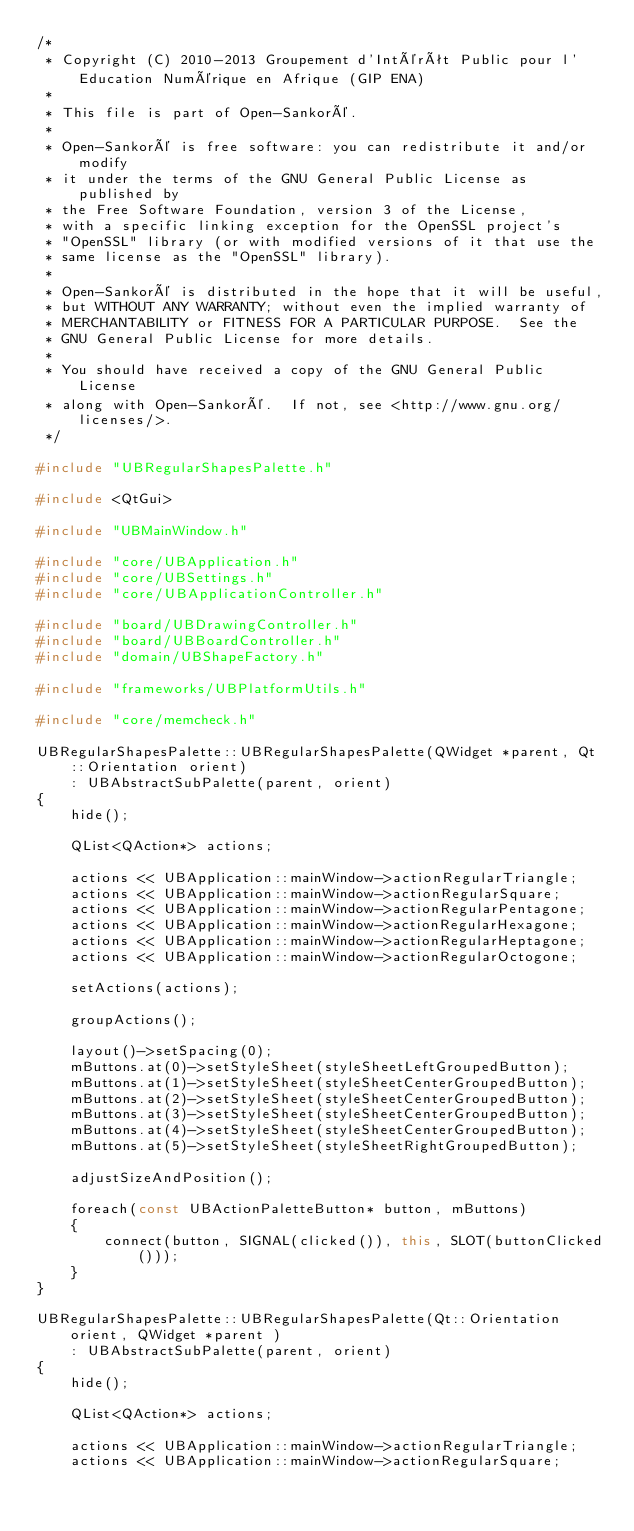<code> <loc_0><loc_0><loc_500><loc_500><_C++_>/*
 * Copyright (C) 2010-2013 Groupement d'Intérêt Public pour l'Education Numérique en Afrique (GIP ENA)
 *
 * This file is part of Open-Sankoré.
 *
 * Open-Sankoré is free software: you can redistribute it and/or modify
 * it under the terms of the GNU General Public License as published by
 * the Free Software Foundation, version 3 of the License,
 * with a specific linking exception for the OpenSSL project's
 * "OpenSSL" library (or with modified versions of it that use the
 * same license as the "OpenSSL" library).
 *
 * Open-Sankoré is distributed in the hope that it will be useful,
 * but WITHOUT ANY WARRANTY; without even the implied warranty of
 * MERCHANTABILITY or FITNESS FOR A PARTICULAR PURPOSE.  See the
 * GNU General Public License for more details.
 *
 * You should have received a copy of the GNU General Public License
 * along with Open-Sankoré.  If not, see <http://www.gnu.org/licenses/>.
 */

#include "UBRegularShapesPalette.h"

#include <QtGui>

#include "UBMainWindow.h"

#include "core/UBApplication.h"
#include "core/UBSettings.h"
#include "core/UBApplicationController.h"

#include "board/UBDrawingController.h"
#include "board/UBBoardController.h"
#include "domain/UBShapeFactory.h"

#include "frameworks/UBPlatformUtils.h"

#include "core/memcheck.h"

UBRegularShapesPalette::UBRegularShapesPalette(QWidget *parent, Qt::Orientation orient)
    : UBAbstractSubPalette(parent, orient)
{
    hide();

    QList<QAction*> actions;

    actions << UBApplication::mainWindow->actionRegularTriangle;
    actions << UBApplication::mainWindow->actionRegularSquare;
    actions << UBApplication::mainWindow->actionRegularPentagone;
    actions << UBApplication::mainWindow->actionRegularHexagone;
    actions << UBApplication::mainWindow->actionRegularHeptagone;
    actions << UBApplication::mainWindow->actionRegularOctogone;            

    setActions(actions);

    groupActions();

    layout()->setSpacing(0);
    mButtons.at(0)->setStyleSheet(styleSheetLeftGroupedButton);
    mButtons.at(1)->setStyleSheet(styleSheetCenterGroupedButton);
    mButtons.at(2)->setStyleSheet(styleSheetCenterGroupedButton);
    mButtons.at(3)->setStyleSheet(styleSheetCenterGroupedButton);
    mButtons.at(4)->setStyleSheet(styleSheetCenterGroupedButton);
    mButtons.at(5)->setStyleSheet(styleSheetRightGroupedButton);

    adjustSizeAndPosition();

    foreach(const UBActionPaletteButton* button, mButtons)
    {
        connect(button, SIGNAL(clicked()), this, SLOT(buttonClicked()));
    }
}

UBRegularShapesPalette::UBRegularShapesPalette(Qt::Orientation orient, QWidget *parent )
    : UBAbstractSubPalette(parent, orient)
{
    hide();

    QList<QAction*> actions;

    actions << UBApplication::mainWindow->actionRegularTriangle;
    actions << UBApplication::mainWindow->actionRegularSquare;</code> 